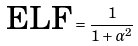<formula> <loc_0><loc_0><loc_500><loc_500>\text {ELF} = \frac { 1 } { 1 + \alpha ^ { 2 } }</formula> 